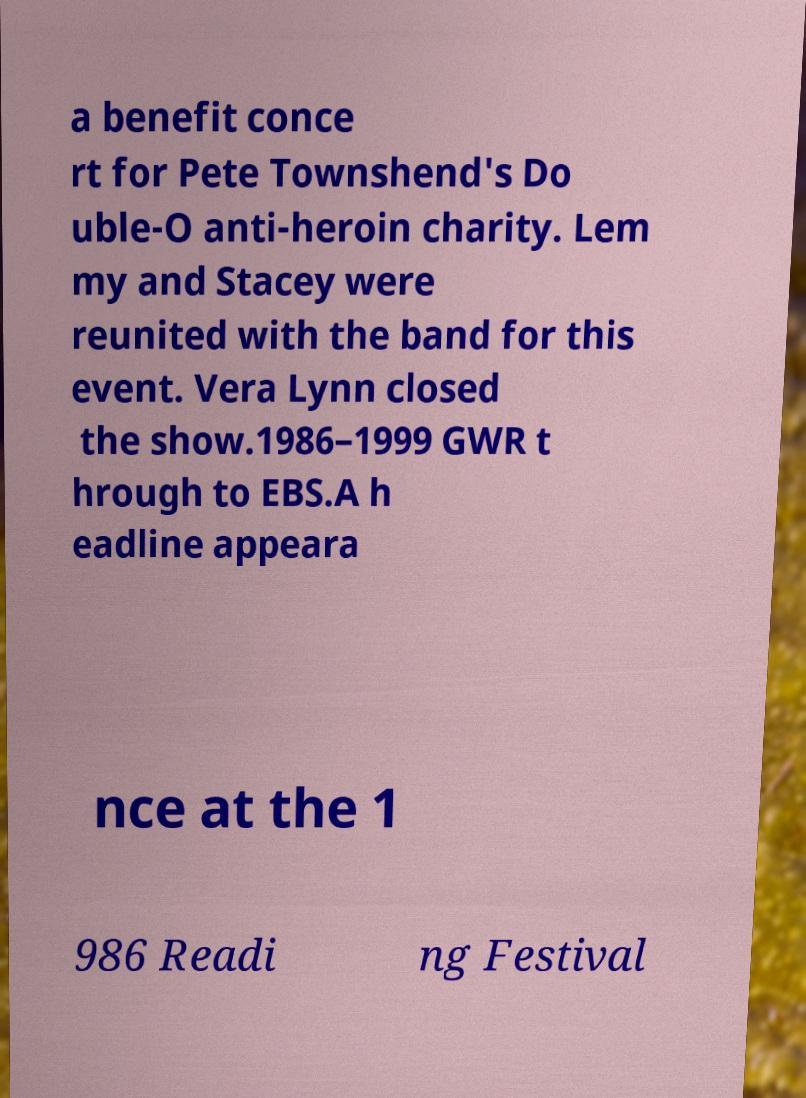Please identify and transcribe the text found in this image. a benefit conce rt for Pete Townshend's Do uble-O anti-heroin charity. Lem my and Stacey were reunited with the band for this event. Vera Lynn closed the show.1986–1999 GWR t hrough to EBS.A h eadline appeara nce at the 1 986 Readi ng Festival 